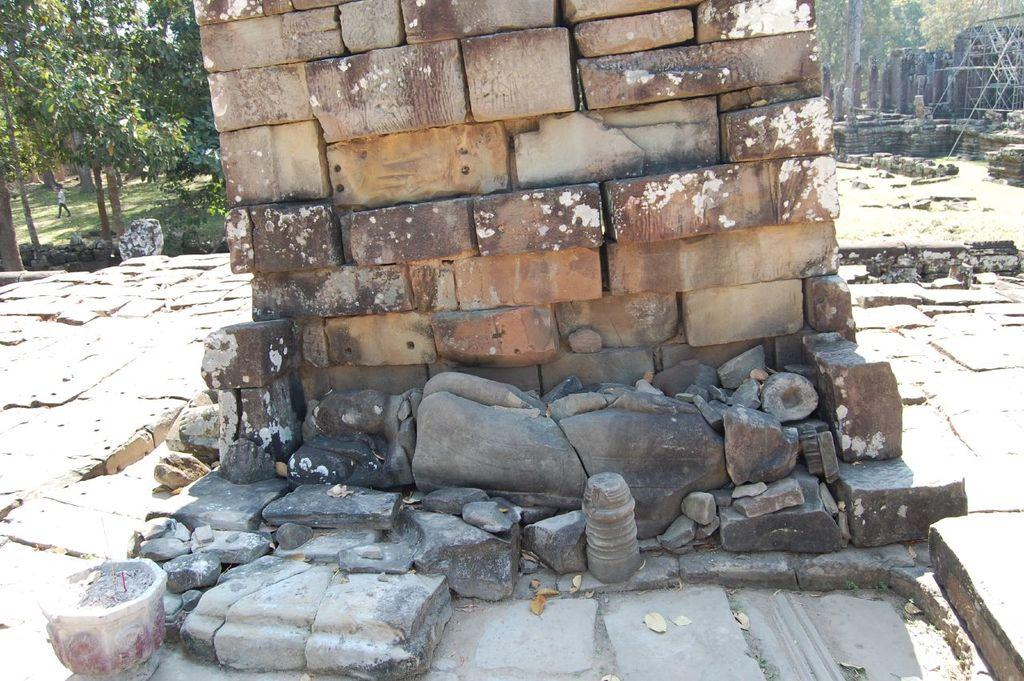What is the main structure in the center of the image? There is a stone wall in the center of the image. What can be seen in the background of the image? There are trees and flat stones in the background of the image. Is there anyone present in the image? Yes, there is a person in the image. What type of rhythm can be heard coming from the stone wall in the image? There is no sound or rhythm associated with the stone wall in the image. 